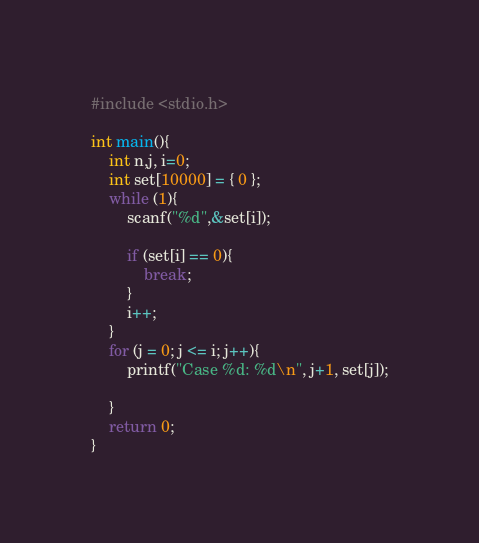Convert code to text. <code><loc_0><loc_0><loc_500><loc_500><_C++_>#include <stdio.h>

int main(){
	int n,j, i=0;
	int set[10000] = { 0 };
	while (1){
		scanf("%d",&set[i]);
		
		if (set[i] == 0){
			break;
		}
		i++;
	}
	for (j = 0; j <= i; j++){
		printf("Case %d: %d\n", j+1, set[j]);

	}
	return 0;
}</code> 